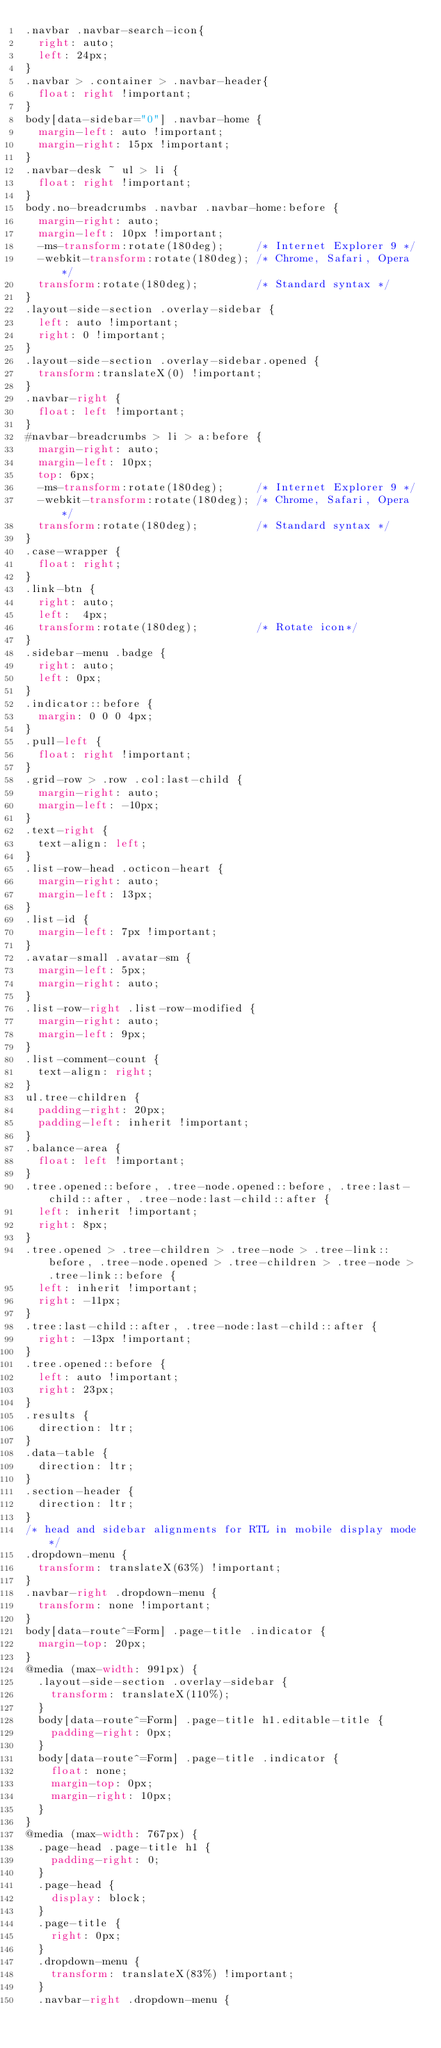<code> <loc_0><loc_0><loc_500><loc_500><_CSS_>.navbar .navbar-search-icon{
  right: auto;
  left: 24px;
}
.navbar > .container > .navbar-header{
  float: right !important;
}
body[data-sidebar="0"] .navbar-home {
  margin-left: auto !important;
  margin-right: 15px !important;
}
.navbar-desk ~ ul > li {
  float: right !important;
}
body.no-breadcrumbs .navbar .navbar-home:before {
  margin-right: auto;
  margin-left: 10px !important;
  -ms-transform:rotate(180deg);     /* Internet Explorer 9 */
  -webkit-transform:rotate(180deg); /* Chrome, Safari, Opera */
  transform:rotate(180deg);         /* Standard syntax */
}
.layout-side-section .overlay-sidebar {
  left: auto !important;
  right: 0 !important;
}
.layout-side-section .overlay-sidebar.opened {
  transform:translateX(0) !important;
}
.navbar-right {
  float: left !important;
}
#navbar-breadcrumbs > li > a:before {
  margin-right: auto;
  margin-left: 10px;
  top: 6px;
  -ms-transform:rotate(180deg);     /* Internet Explorer 9 */
  -webkit-transform:rotate(180deg); /* Chrome, Safari, Opera */
  transform:rotate(180deg);         /* Standard syntax */
}
.case-wrapper {
  float: right;
}
.link-btn {
  right: auto;
  left:  4px;
  transform:rotate(180deg);         /* Rotate icon*/
}
.sidebar-menu .badge {
  right: auto;
  left: 0px;
}
.indicator::before {
  margin: 0 0 0 4px;
}
.pull-left {
  float: right !important;
}
.grid-row > .row .col:last-child {
  margin-right: auto;
  margin-left: -10px;
}
.text-right {
  text-align: left;
}
.list-row-head .octicon-heart {
  margin-right: auto;
  margin-left: 13px;
}
.list-id {
  margin-left: 7px !important;
}
.avatar-small .avatar-sm {
  margin-left: 5px;
  margin-right: auto;
}
.list-row-right .list-row-modified {
  margin-right: auto;
  margin-left: 9px;
}
.list-comment-count {
  text-align: right;
}
ul.tree-children {
  padding-right: 20px;
  padding-left: inherit !important;
}
.balance-area {
  float: left !important;
}
.tree.opened::before, .tree-node.opened::before, .tree:last-child::after, .tree-node:last-child::after {
  left: inherit !important;
  right: 8px;
}
.tree.opened > .tree-children > .tree-node > .tree-link::before, .tree-node.opened > .tree-children > .tree-node > .tree-link::before {
  left: inherit !important;
  right: -11px;
}
.tree:last-child::after, .tree-node:last-child::after {
  right: -13px !important;
}
.tree.opened::before {
  left: auto !important;
  right: 23px;
}
.results {
  direction: ltr;
}
.data-table {
  direction: ltr;
}
.section-header {
  direction: ltr;
}
/* head and sidebar alignments for RTL in mobile display mode */
.dropdown-menu {
  transform: translateX(63%) !important;
}
.navbar-right .dropdown-menu {
  transform: none !important;
}
body[data-route^=Form] .page-title .indicator {
  margin-top: 20px;
}
@media (max-width: 991px) {
  .layout-side-section .overlay-sidebar {
    transform: translateX(110%);
  }
  body[data-route^=Form] .page-title h1.editable-title {
    padding-right: 0px;
  }
  body[data-route^=Form] .page-title .indicator {
    float: none;
    margin-top: 0px;
    margin-right: 10px;
  }
}
@media (max-width: 767px) {
  .page-head .page-title h1 {
    padding-right: 0;
  }
  .page-head {
    display: block;
  }
  .page-title {
    right: 0px;
  }
  .dropdown-menu {
    transform: translateX(83%) !important;
  }
  .navbar-right .dropdown-menu {</code> 